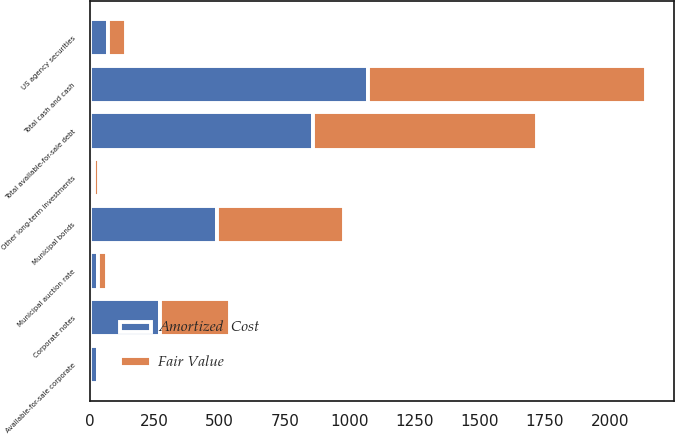Convert chart. <chart><loc_0><loc_0><loc_500><loc_500><stacked_bar_chart><ecel><fcel>Total cash and cash<fcel>Municipal bonds<fcel>Municipal auction rate<fcel>Corporate notes<fcel>US agency securities<fcel>Total available-for-sale debt<fcel>Available-for-sale corporate<fcel>Other long-term investments<nl><fcel>Fair Value<fcel>1069<fcel>489<fcel>33<fcel>269<fcel>69<fcel>860<fcel>5<fcel>17<nl><fcel>Amortized  Cost<fcel>1069<fcel>489<fcel>33<fcel>269<fcel>69<fcel>860<fcel>33<fcel>17<nl></chart> 